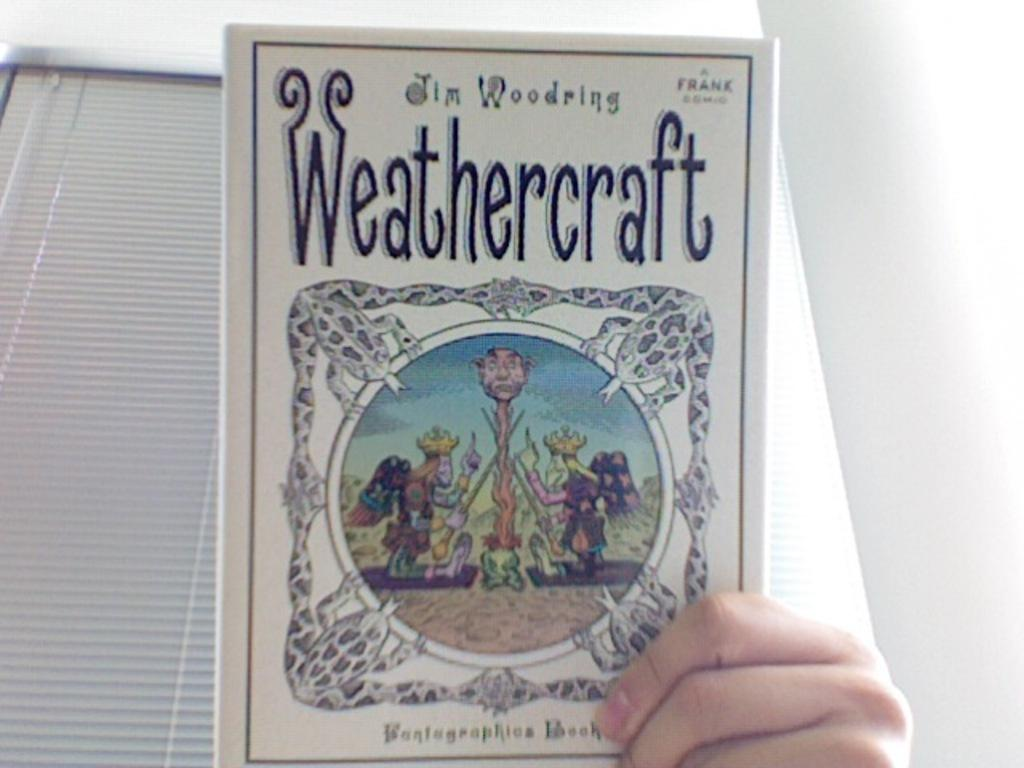<image>
Present a compact description of the photo's key features. A hand is holding a book entitled Weathercraft. 